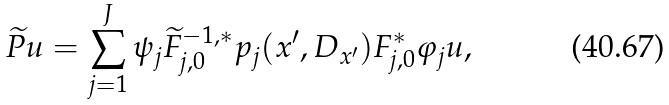Convert formula to latex. <formula><loc_0><loc_0><loc_500><loc_500>\widetilde { P } u = \sum _ { j = 1 } ^ { J } \psi _ { j } \widetilde { F } _ { j , 0 } ^ { - 1 , \ast } p _ { j } ( x ^ { \prime } , D _ { x ^ { \prime } } ) F _ { j , 0 } ^ { \ast } \varphi _ { j } u ,</formula> 